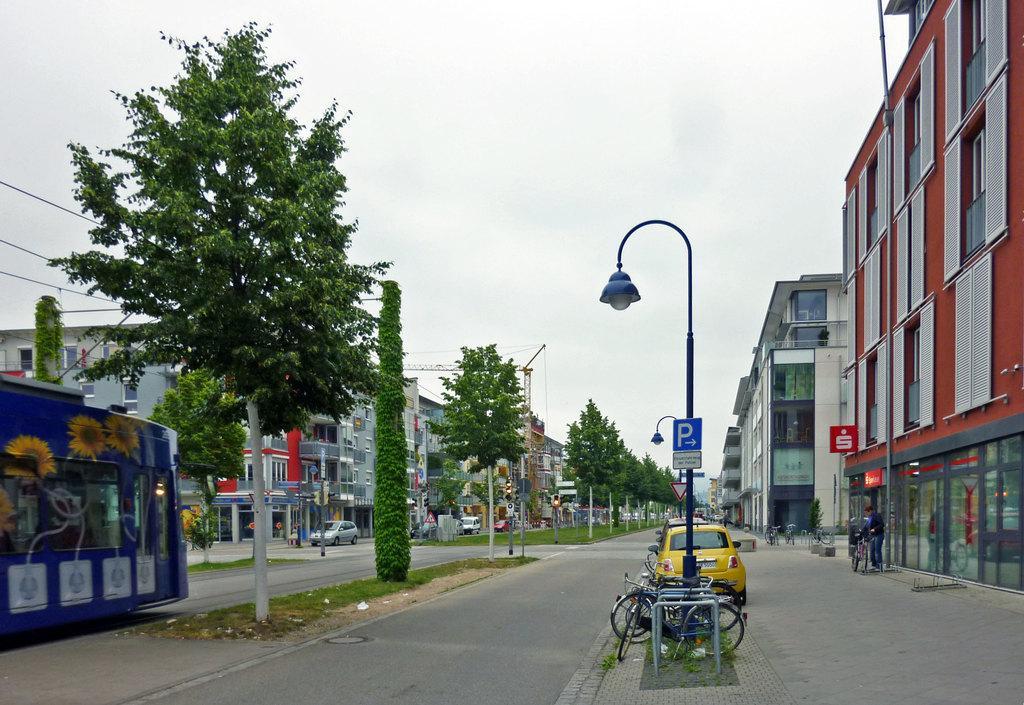Could you give a brief overview of what you see in this image? In this image we can see there are buildings and there are vehicles on the road. We can see there are trees, grass, street light, rods, crane and the sky. 